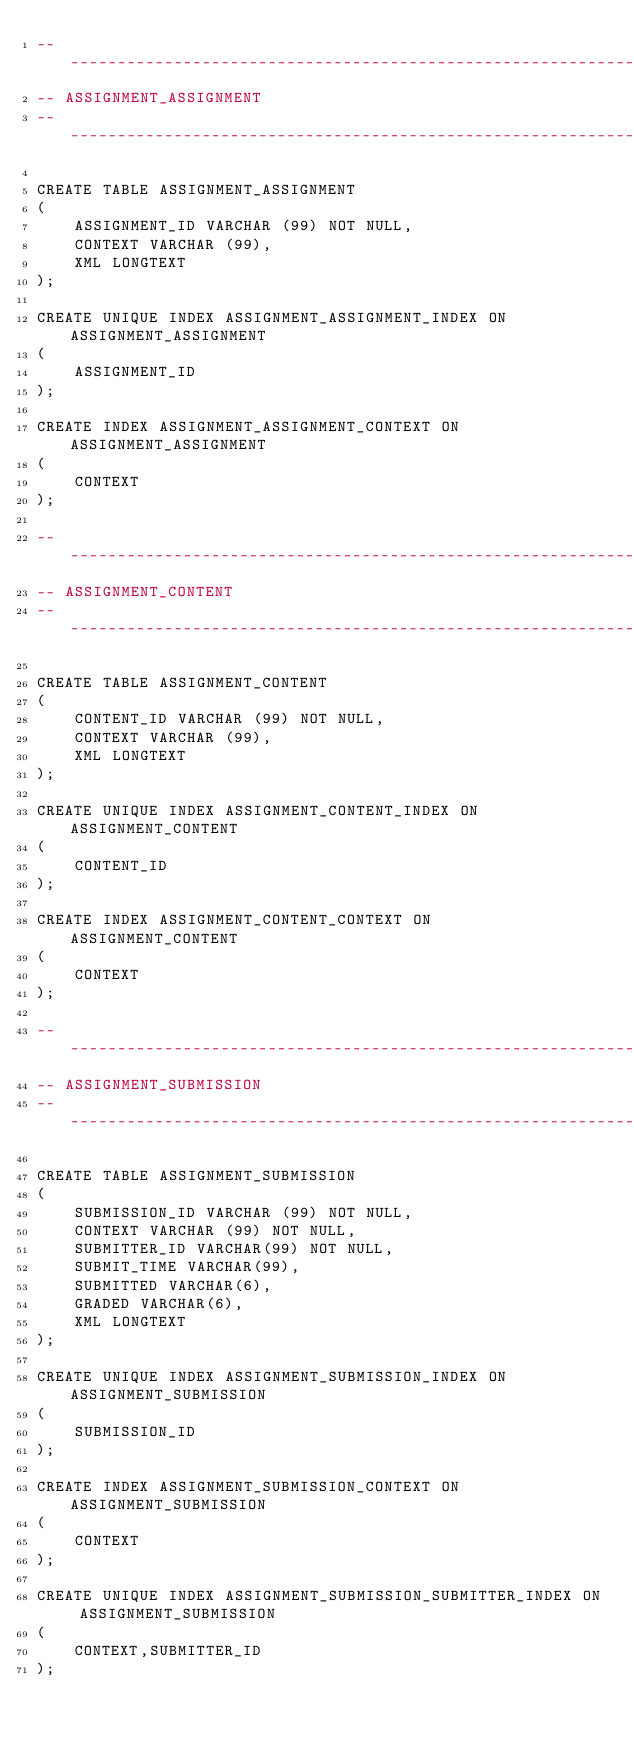Convert code to text. <code><loc_0><loc_0><loc_500><loc_500><_SQL_>-- ---------------------------------------------------------------------------
-- ASSIGNMENT_ASSIGNMENT
-- ---------------------------------------------------------------------------

CREATE TABLE ASSIGNMENT_ASSIGNMENT
(
    ASSIGNMENT_ID VARCHAR (99) NOT NULL,
	CONTEXT VARCHAR (99),
    XML LONGTEXT
);

CREATE UNIQUE INDEX ASSIGNMENT_ASSIGNMENT_INDEX ON ASSIGNMENT_ASSIGNMENT
(
	ASSIGNMENT_ID
);

CREATE INDEX ASSIGNMENT_ASSIGNMENT_CONTEXT ON ASSIGNMENT_ASSIGNMENT
(
	CONTEXT
);

-- ---------------------------------------------------------------------------
-- ASSIGNMENT_CONTENT
-- ---------------------------------------------------------------------------

CREATE TABLE ASSIGNMENT_CONTENT
(
    CONTENT_ID VARCHAR (99) NOT NULL,
	CONTEXT VARCHAR (99),
    XML LONGTEXT
);

CREATE UNIQUE INDEX ASSIGNMENT_CONTENT_INDEX ON ASSIGNMENT_CONTENT
(
	CONTENT_ID
);

CREATE INDEX ASSIGNMENT_CONTENT_CONTEXT ON ASSIGNMENT_CONTENT
(
	CONTEXT
);

-- ---------------------------------------------------------------------------
-- ASSIGNMENT_SUBMISSION
-- ---------------------------------------------------------------------------

CREATE TABLE ASSIGNMENT_SUBMISSION
(
    SUBMISSION_ID VARCHAR (99) NOT NULL,
	CONTEXT VARCHAR (99) NOT NULL,
	SUBMITTER_ID VARCHAR(99) NOT NULL,
	SUBMIT_TIME VARCHAR(99),
	SUBMITTED VARCHAR(6),
	GRADED VARCHAR(6),
    XML LONGTEXT
);

CREATE UNIQUE INDEX ASSIGNMENT_SUBMISSION_INDEX ON ASSIGNMENT_SUBMISSION
(
	SUBMISSION_ID
);

CREATE INDEX ASSIGNMENT_SUBMISSION_CONTEXT ON ASSIGNMENT_SUBMISSION
(
	CONTEXT
);

CREATE UNIQUE INDEX ASSIGNMENT_SUBMISSION_SUBMITTER_INDEX ON ASSIGNMENT_SUBMISSION
(
	CONTEXT,SUBMITTER_ID
);
</code> 